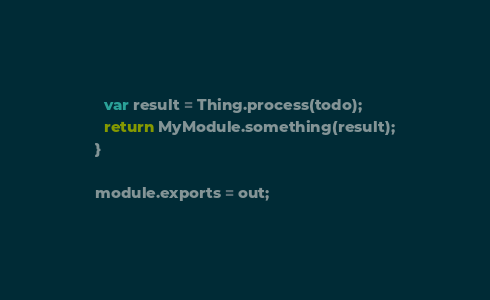<code> <loc_0><loc_0><loc_500><loc_500><_JavaScript_>  var result = Thing.process(todo);
  return MyModule.something(result);
}

module.exports = out;</code> 